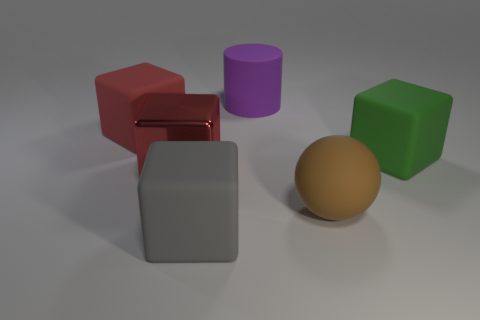Which object appears closest to the perspective of the viewer, and how can we determine this visually? The red cube appears to be the closest object to the viewer's perspective. We can determine this visually because it is the largest in apparent size, it overlaps the edges of other objects, and it is positioned in the foreground of the composition, with clear space around its borders.  Based on the composition, can you infer anything about the context or setting these objects are in? The objects are positioned on a flat, neutral surface with a horizon line suggesting an indoor studio setting or a simulation. The even lighting and lack of additional elements like textures or background objects imply that the focus is meant to be on the shapes, colors, and materials of the objects rather than their context. 